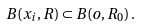<formula> <loc_0><loc_0><loc_500><loc_500>B ( x _ { i } , R ) \subset B ( o , R _ { 0 } ) \, .</formula> 